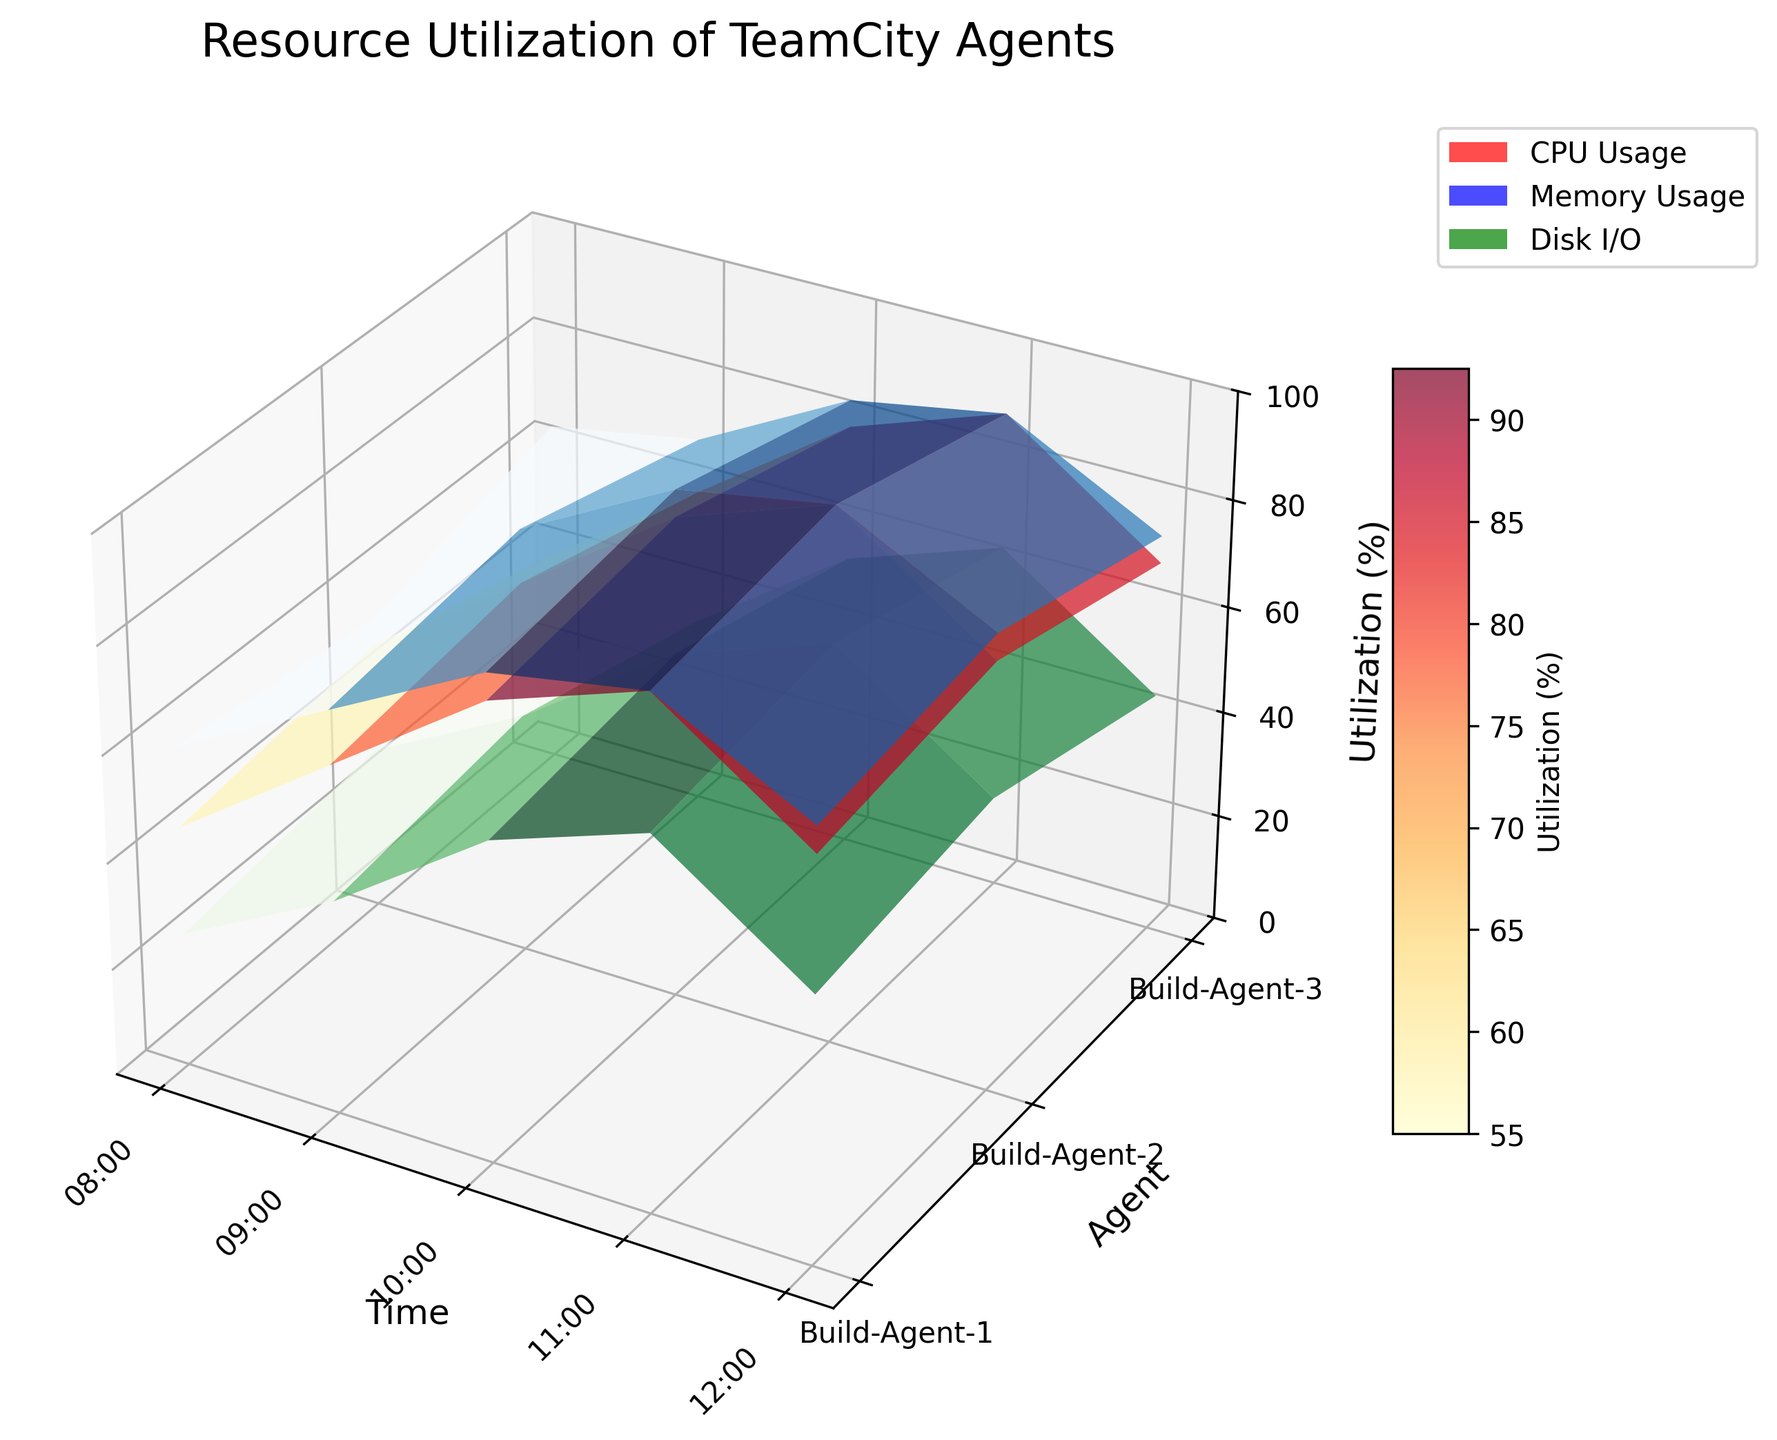what is the highest CPU utilization observed among the agents? The highest point of the CPU utilization surface plot indicates the peak CPU usage. Based on the colored surface height, this is observed on "Build-Agent-2" at 11:00.
Answer: 100% Which agent had the maximum memory usage at 10:00? To find the memory usage at 10:00, observe the midpoint Y position (Build-Agent-2) on the graph. The corresponding height of the blue surface indicates the maximum memory usage.
Answer: Build-Agent-2 How did the disk I/O usage of Build-Agent-3 compare between 09:00 and 11:00? Compare the green height peaks for Build-Agent-3 at 09:00 and 11:00. The height at 09:00 is lower (35) compared to 11:00 (65), indicating an increase.
Answer: Increased Is CPU usage for any agent constant over different times? Examining the CPU usage surface, no single agent has a uniform height across different times; usage either increases or fluctuates.
Answer: No What is the overall trend of memory usage for Build-Agent-1? Observe the blue height endpoints for Build-Agent-1 at different times. Memory usage increases from 60 at 08:00 to 95 at 11:00, then declines slightly.
Answer: Increasing, then decreasing Which metric shows the greatest variability for Build-Agent-2? Compare the height of surfaces (CPU, memory, and disk I/O). The greatest differences in heights are observed in the CPU utilization between 08:00 and 11:00.
Answer: CPU How does the resource utilization pattern of Build-Agent-1 from 09:00 to 12:00 compare with Build-Agent-3's? Evaluating the surface heights for all three metrics between 09:00 and 12:00, Build-Agent-1 starts high and later decreases sharply, whereas Build-Agent-3 remains more stable but still shows a decline.
Answer: More fluctuation in Build-Agent-1 At which time does Build-Agent-3 have the highest CPU utilization? Identify the peak of the red surface for Build-Agent-3. The highest point is at 11:00.
Answer: 11:00 Are there any agents that experienced utilization rates that never reached 100% for both CPU and memory? By evaluating both the red and blue surfaces for each plot, Build-Agent-1 and Build-Agent-3 do not reach the 100% mark for both metrics.
Answer: Build-Agent-1 and Build-Agent-3 